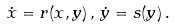Convert formula to latex. <formula><loc_0><loc_0><loc_500><loc_500>\dot { x } = r ( x , y ) \, , \, \dot { y } = s ( y ) \, .</formula> 